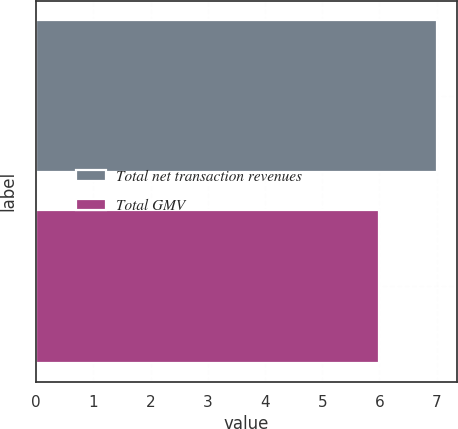Convert chart to OTSL. <chart><loc_0><loc_0><loc_500><loc_500><bar_chart><fcel>Total net transaction revenues<fcel>Total GMV<nl><fcel>7<fcel>6<nl></chart> 